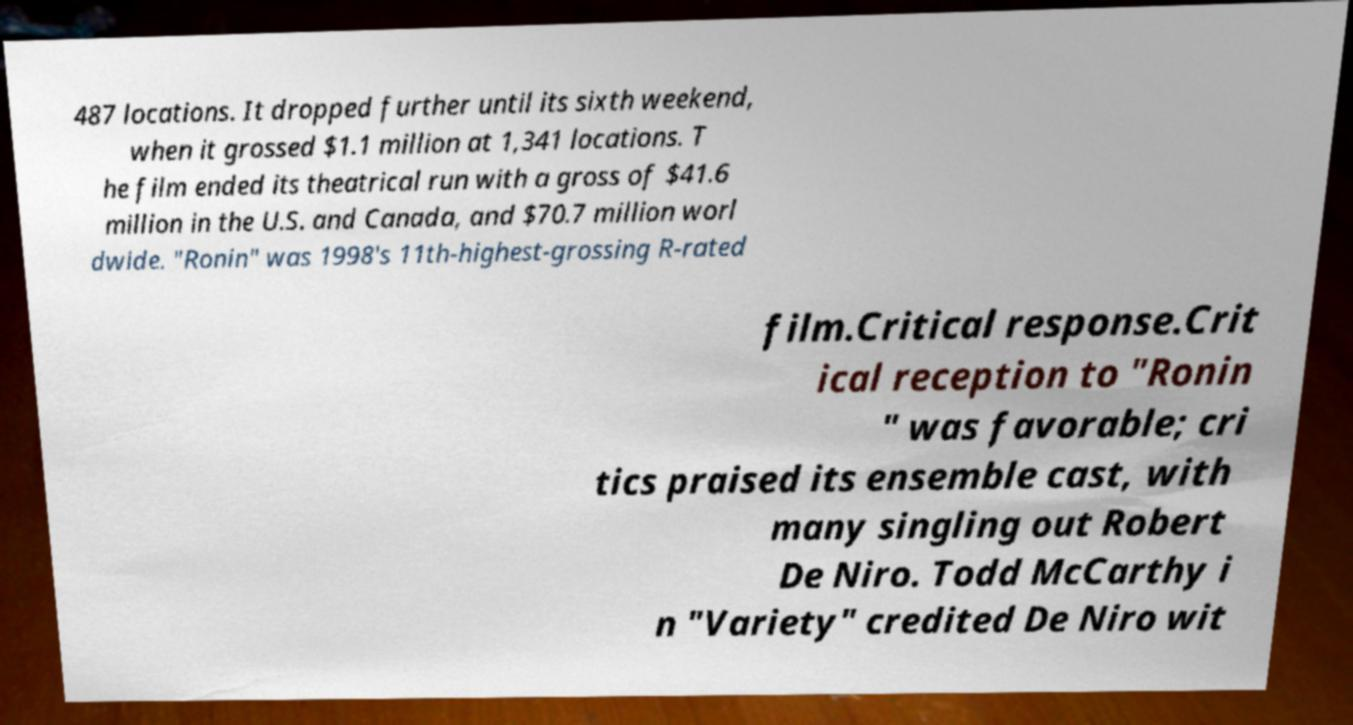There's text embedded in this image that I need extracted. Can you transcribe it verbatim? 487 locations. It dropped further until its sixth weekend, when it grossed $1.1 million at 1,341 locations. T he film ended its theatrical run with a gross of $41.6 million in the U.S. and Canada, and $70.7 million worl dwide. "Ronin" was 1998's 11th-highest-grossing R-rated film.Critical response.Crit ical reception to "Ronin " was favorable; cri tics praised its ensemble cast, with many singling out Robert De Niro. Todd McCarthy i n "Variety" credited De Niro wit 